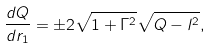Convert formula to latex. <formula><loc_0><loc_0><loc_500><loc_500>\frac { d Q } { d r _ { 1 } } = \pm 2 \sqrt { 1 + \Gamma ^ { 2 } } \sqrt { Q - l ^ { 2 } } ,</formula> 